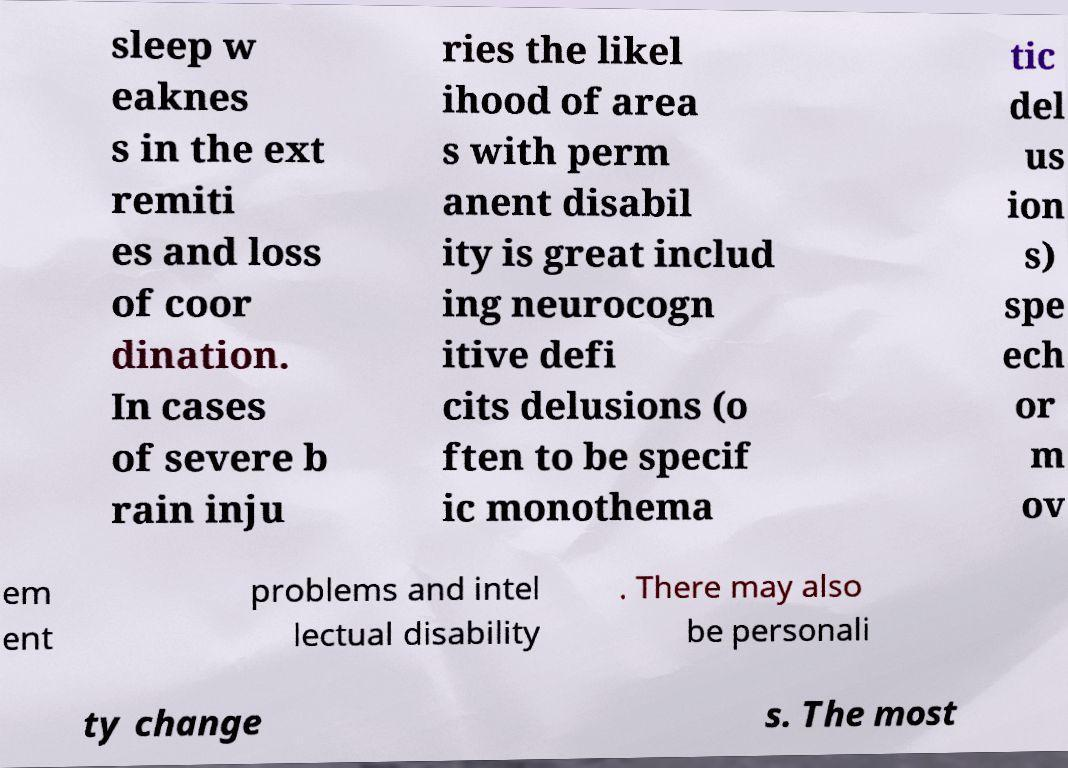I need the written content from this picture converted into text. Can you do that? sleep w eaknes s in the ext remiti es and loss of coor dination. In cases of severe b rain inju ries the likel ihood of area s with perm anent disabil ity is great includ ing neurocogn itive defi cits delusions (o ften to be specif ic monothema tic del us ion s) spe ech or m ov em ent problems and intel lectual disability . There may also be personali ty change s. The most 